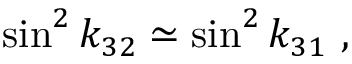Convert formula to latex. <formula><loc_0><loc_0><loc_500><loc_500>\sin ^ { 2 } k _ { 3 2 } \simeq \sin ^ { 2 } k _ { 3 1 } \ ,</formula> 